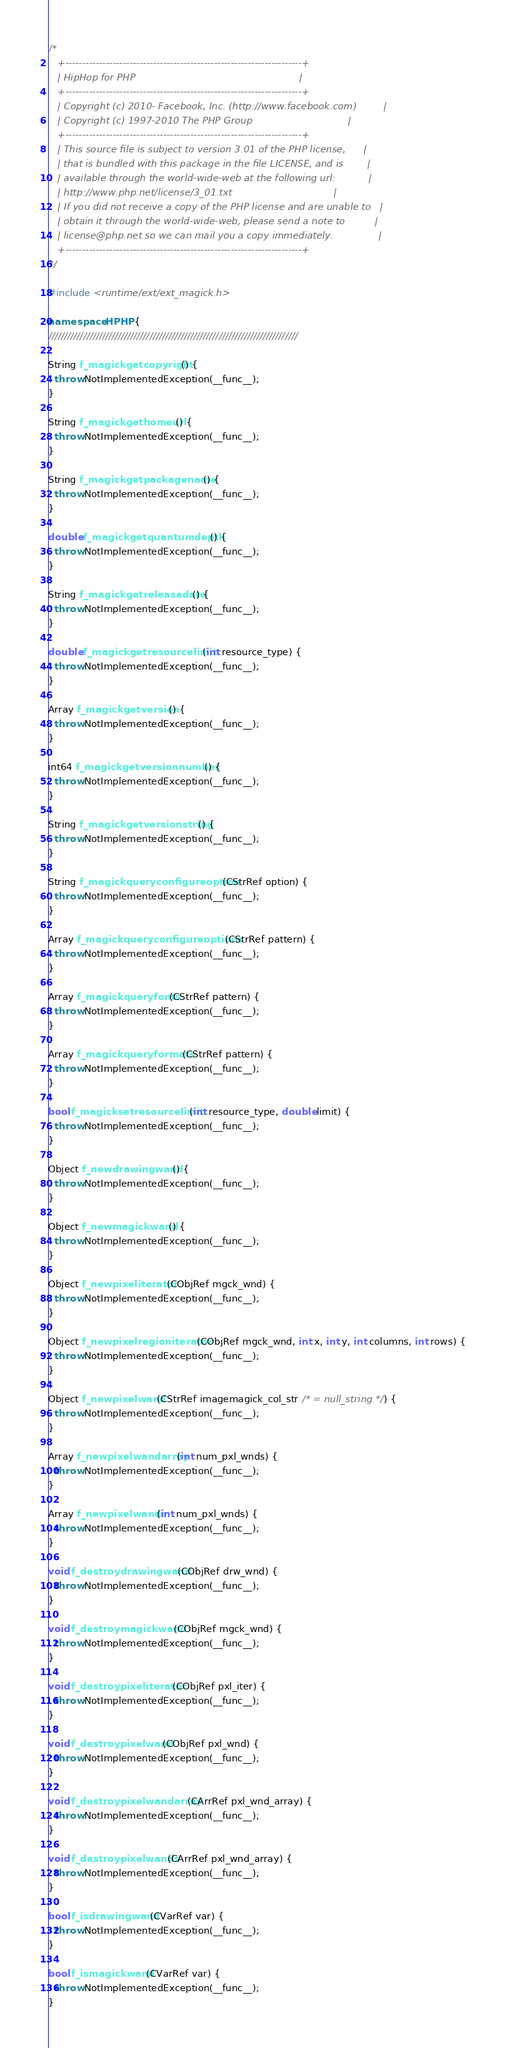<code> <loc_0><loc_0><loc_500><loc_500><_C++_>/*
   +----------------------------------------------------------------------+
   | HipHop for PHP                                                       |
   +----------------------------------------------------------------------+
   | Copyright (c) 2010- Facebook, Inc. (http://www.facebook.com)         |
   | Copyright (c) 1997-2010 The PHP Group                                |
   +----------------------------------------------------------------------+
   | This source file is subject to version 3.01 of the PHP license,      |
   | that is bundled with this package in the file LICENSE, and is        |
   | available through the world-wide-web at the following url:           |
   | http://www.php.net/license/3_01.txt                                  |
   | If you did not receive a copy of the PHP license and are unable to   |
   | obtain it through the world-wide-web, please send a note to          |
   | license@php.net so we can mail you a copy immediately.               |
   +----------------------------------------------------------------------+
*/

#include <runtime/ext/ext_magick.h>

namespace HPHP {
///////////////////////////////////////////////////////////////////////////////

String f_magickgetcopyright() {
  throw NotImplementedException(__func__);
}

String f_magickgethomeurl() {
  throw NotImplementedException(__func__);
}

String f_magickgetpackagename() {
  throw NotImplementedException(__func__);
}

double f_magickgetquantumdepth() {
  throw NotImplementedException(__func__);
}

String f_magickgetreleasedate() {
  throw NotImplementedException(__func__);
}

double f_magickgetresourcelimit(int resource_type) {
  throw NotImplementedException(__func__);
}

Array f_magickgetversion() {
  throw NotImplementedException(__func__);
}

int64 f_magickgetversionnumber() {
  throw NotImplementedException(__func__);
}

String f_magickgetversionstring() {
  throw NotImplementedException(__func__);
}

String f_magickqueryconfigureoption(CStrRef option) {
  throw NotImplementedException(__func__);
}

Array f_magickqueryconfigureoptions(CStrRef pattern) {
  throw NotImplementedException(__func__);
}

Array f_magickqueryfonts(CStrRef pattern) {
  throw NotImplementedException(__func__);
}

Array f_magickqueryformats(CStrRef pattern) {
  throw NotImplementedException(__func__);
}

bool f_magicksetresourcelimit(int resource_type, double limit) {
  throw NotImplementedException(__func__);
}

Object f_newdrawingwand() {
  throw NotImplementedException(__func__);
}

Object f_newmagickwand() {
  throw NotImplementedException(__func__);
}

Object f_newpixeliterator(CObjRef mgck_wnd) {
  throw NotImplementedException(__func__);
}

Object f_newpixelregioniterator(CObjRef mgck_wnd, int x, int y, int columns, int rows) {
  throw NotImplementedException(__func__);
}

Object f_newpixelwand(CStrRef imagemagick_col_str /* = null_string */) {
  throw NotImplementedException(__func__);
}

Array f_newpixelwandarray(int num_pxl_wnds) {
  throw NotImplementedException(__func__);
}

Array f_newpixelwands(int num_pxl_wnds) {
  throw NotImplementedException(__func__);
}

void f_destroydrawingwand(CObjRef drw_wnd) {
  throw NotImplementedException(__func__);
}

void f_destroymagickwand(CObjRef mgck_wnd) {
  throw NotImplementedException(__func__);
}

void f_destroypixeliterator(CObjRef pxl_iter) {
  throw NotImplementedException(__func__);
}

void f_destroypixelwand(CObjRef pxl_wnd) {
  throw NotImplementedException(__func__);
}

void f_destroypixelwandarray(CArrRef pxl_wnd_array) {
  throw NotImplementedException(__func__);
}

void f_destroypixelwands(CArrRef pxl_wnd_array) {
  throw NotImplementedException(__func__);
}

bool f_isdrawingwand(CVarRef var) {
  throw NotImplementedException(__func__);
}

bool f_ismagickwand(CVarRef var) {
  throw NotImplementedException(__func__);
}
</code> 